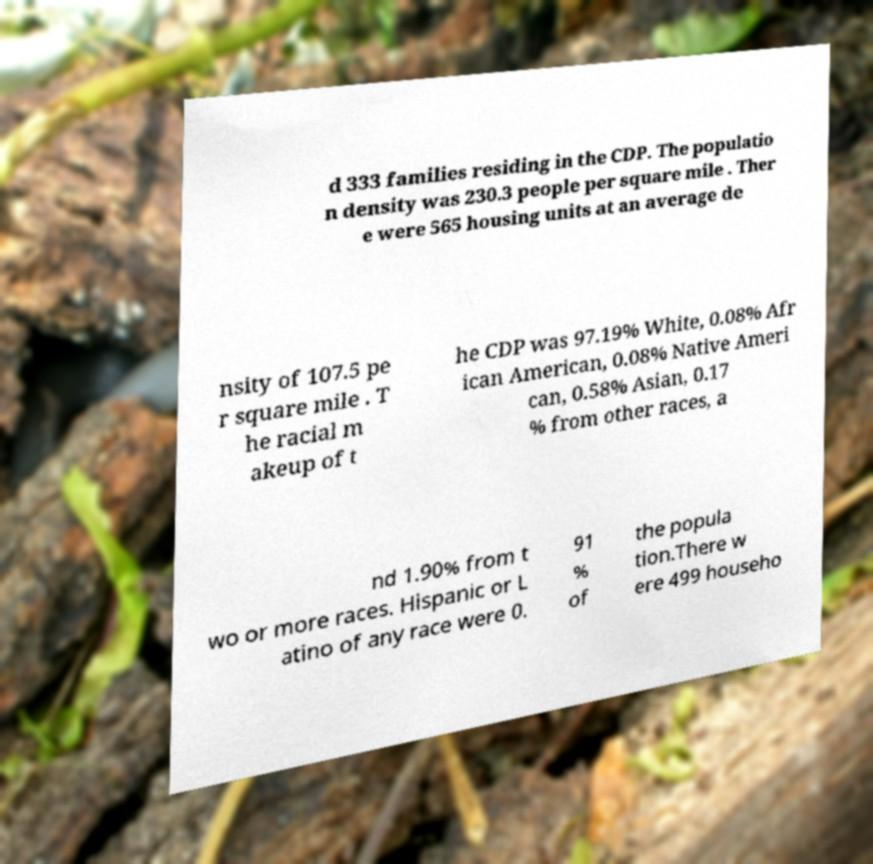Could you extract and type out the text from this image? d 333 families residing in the CDP. The populatio n density was 230.3 people per square mile . Ther e were 565 housing units at an average de nsity of 107.5 pe r square mile . T he racial m akeup of t he CDP was 97.19% White, 0.08% Afr ican American, 0.08% Native Ameri can, 0.58% Asian, 0.17 % from other races, a nd 1.90% from t wo or more races. Hispanic or L atino of any race were 0. 91 % of the popula tion.There w ere 499 househo 